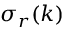Convert formula to latex. <formula><loc_0><loc_0><loc_500><loc_500>\sigma _ { r } ( k )</formula> 